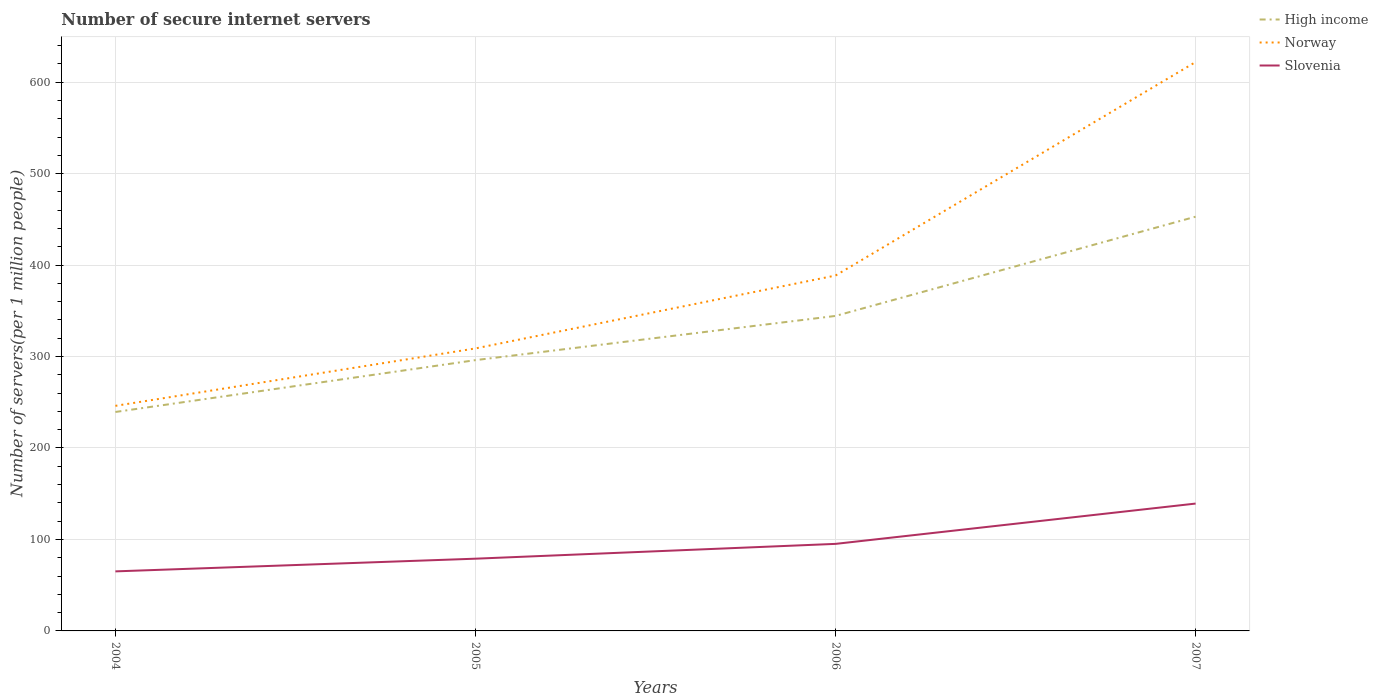How many different coloured lines are there?
Make the answer very short. 3. Is the number of lines equal to the number of legend labels?
Provide a short and direct response. Yes. Across all years, what is the maximum number of secure internet servers in High income?
Offer a terse response. 239.39. In which year was the number of secure internet servers in Slovenia maximum?
Keep it short and to the point. 2004. What is the total number of secure internet servers in Slovenia in the graph?
Your answer should be very brief. -16.19. What is the difference between the highest and the second highest number of secure internet servers in Norway?
Offer a terse response. 375.9. How many lines are there?
Provide a short and direct response. 3. Are the values on the major ticks of Y-axis written in scientific E-notation?
Make the answer very short. No. Does the graph contain any zero values?
Your response must be concise. No. Does the graph contain grids?
Offer a very short reply. Yes. Where does the legend appear in the graph?
Provide a short and direct response. Top right. How many legend labels are there?
Provide a succinct answer. 3. What is the title of the graph?
Keep it short and to the point. Number of secure internet servers. Does "Central Europe" appear as one of the legend labels in the graph?
Provide a short and direct response. No. What is the label or title of the Y-axis?
Your answer should be very brief. Number of servers(per 1 million people). What is the Number of servers(per 1 million people) of High income in 2004?
Make the answer very short. 239.39. What is the Number of servers(per 1 million people) of Norway in 2004?
Your answer should be compact. 246.08. What is the Number of servers(per 1 million people) in Slovenia in 2004?
Ensure brevity in your answer.  65.1. What is the Number of servers(per 1 million people) in High income in 2005?
Provide a succinct answer. 296.07. What is the Number of servers(per 1 million people) of Norway in 2005?
Keep it short and to the point. 308.87. What is the Number of servers(per 1 million people) of Slovenia in 2005?
Ensure brevity in your answer.  78.98. What is the Number of servers(per 1 million people) in High income in 2006?
Ensure brevity in your answer.  344.4. What is the Number of servers(per 1 million people) in Norway in 2006?
Keep it short and to the point. 388.57. What is the Number of servers(per 1 million people) in Slovenia in 2006?
Offer a terse response. 95.17. What is the Number of servers(per 1 million people) of High income in 2007?
Make the answer very short. 452.9. What is the Number of servers(per 1 million people) of Norway in 2007?
Offer a very short reply. 621.98. What is the Number of servers(per 1 million people) in Slovenia in 2007?
Make the answer very short. 139.24. Across all years, what is the maximum Number of servers(per 1 million people) in High income?
Offer a very short reply. 452.9. Across all years, what is the maximum Number of servers(per 1 million people) of Norway?
Keep it short and to the point. 621.98. Across all years, what is the maximum Number of servers(per 1 million people) of Slovenia?
Ensure brevity in your answer.  139.24. Across all years, what is the minimum Number of servers(per 1 million people) of High income?
Offer a terse response. 239.39. Across all years, what is the minimum Number of servers(per 1 million people) in Norway?
Provide a succinct answer. 246.08. Across all years, what is the minimum Number of servers(per 1 million people) in Slovenia?
Give a very brief answer. 65.1. What is the total Number of servers(per 1 million people) of High income in the graph?
Provide a succinct answer. 1332.76. What is the total Number of servers(per 1 million people) of Norway in the graph?
Keep it short and to the point. 1565.51. What is the total Number of servers(per 1 million people) of Slovenia in the graph?
Your answer should be very brief. 378.49. What is the difference between the Number of servers(per 1 million people) of High income in 2004 and that in 2005?
Ensure brevity in your answer.  -56.67. What is the difference between the Number of servers(per 1 million people) in Norway in 2004 and that in 2005?
Offer a terse response. -62.79. What is the difference between the Number of servers(per 1 million people) of Slovenia in 2004 and that in 2005?
Offer a terse response. -13.88. What is the difference between the Number of servers(per 1 million people) in High income in 2004 and that in 2006?
Keep it short and to the point. -105.01. What is the difference between the Number of servers(per 1 million people) in Norway in 2004 and that in 2006?
Make the answer very short. -142.49. What is the difference between the Number of servers(per 1 million people) of Slovenia in 2004 and that in 2006?
Make the answer very short. -30.08. What is the difference between the Number of servers(per 1 million people) of High income in 2004 and that in 2007?
Your answer should be compact. -213.51. What is the difference between the Number of servers(per 1 million people) in Norway in 2004 and that in 2007?
Keep it short and to the point. -375.9. What is the difference between the Number of servers(per 1 million people) of Slovenia in 2004 and that in 2007?
Your response must be concise. -74.14. What is the difference between the Number of servers(per 1 million people) in High income in 2005 and that in 2006?
Offer a very short reply. -48.34. What is the difference between the Number of servers(per 1 million people) in Norway in 2005 and that in 2006?
Your answer should be very brief. -79.7. What is the difference between the Number of servers(per 1 million people) in Slovenia in 2005 and that in 2006?
Make the answer very short. -16.19. What is the difference between the Number of servers(per 1 million people) of High income in 2005 and that in 2007?
Offer a terse response. -156.84. What is the difference between the Number of servers(per 1 million people) in Norway in 2005 and that in 2007?
Provide a short and direct response. -313.11. What is the difference between the Number of servers(per 1 million people) of Slovenia in 2005 and that in 2007?
Make the answer very short. -60.26. What is the difference between the Number of servers(per 1 million people) of High income in 2006 and that in 2007?
Give a very brief answer. -108.5. What is the difference between the Number of servers(per 1 million people) in Norway in 2006 and that in 2007?
Make the answer very short. -233.41. What is the difference between the Number of servers(per 1 million people) in Slovenia in 2006 and that in 2007?
Provide a succinct answer. -44.07. What is the difference between the Number of servers(per 1 million people) of High income in 2004 and the Number of servers(per 1 million people) of Norway in 2005?
Make the answer very short. -69.48. What is the difference between the Number of servers(per 1 million people) of High income in 2004 and the Number of servers(per 1 million people) of Slovenia in 2005?
Your answer should be very brief. 160.41. What is the difference between the Number of servers(per 1 million people) of Norway in 2004 and the Number of servers(per 1 million people) of Slovenia in 2005?
Your answer should be very brief. 167.1. What is the difference between the Number of servers(per 1 million people) of High income in 2004 and the Number of servers(per 1 million people) of Norway in 2006?
Make the answer very short. -149.18. What is the difference between the Number of servers(per 1 million people) of High income in 2004 and the Number of servers(per 1 million people) of Slovenia in 2006?
Offer a terse response. 144.22. What is the difference between the Number of servers(per 1 million people) of Norway in 2004 and the Number of servers(per 1 million people) of Slovenia in 2006?
Ensure brevity in your answer.  150.91. What is the difference between the Number of servers(per 1 million people) in High income in 2004 and the Number of servers(per 1 million people) in Norway in 2007?
Ensure brevity in your answer.  -382.59. What is the difference between the Number of servers(per 1 million people) of High income in 2004 and the Number of servers(per 1 million people) of Slovenia in 2007?
Your answer should be compact. 100.15. What is the difference between the Number of servers(per 1 million people) in Norway in 2004 and the Number of servers(per 1 million people) in Slovenia in 2007?
Offer a very short reply. 106.85. What is the difference between the Number of servers(per 1 million people) of High income in 2005 and the Number of servers(per 1 million people) of Norway in 2006?
Provide a short and direct response. -92.5. What is the difference between the Number of servers(per 1 million people) in High income in 2005 and the Number of servers(per 1 million people) in Slovenia in 2006?
Your answer should be very brief. 200.89. What is the difference between the Number of servers(per 1 million people) in Norway in 2005 and the Number of servers(per 1 million people) in Slovenia in 2006?
Ensure brevity in your answer.  213.7. What is the difference between the Number of servers(per 1 million people) in High income in 2005 and the Number of servers(per 1 million people) in Norway in 2007?
Provide a succinct answer. -325.91. What is the difference between the Number of servers(per 1 million people) in High income in 2005 and the Number of servers(per 1 million people) in Slovenia in 2007?
Give a very brief answer. 156.83. What is the difference between the Number of servers(per 1 million people) of Norway in 2005 and the Number of servers(per 1 million people) of Slovenia in 2007?
Provide a short and direct response. 169.63. What is the difference between the Number of servers(per 1 million people) in High income in 2006 and the Number of servers(per 1 million people) in Norway in 2007?
Your answer should be very brief. -277.58. What is the difference between the Number of servers(per 1 million people) of High income in 2006 and the Number of servers(per 1 million people) of Slovenia in 2007?
Offer a terse response. 205.17. What is the difference between the Number of servers(per 1 million people) in Norway in 2006 and the Number of servers(per 1 million people) in Slovenia in 2007?
Provide a short and direct response. 249.33. What is the average Number of servers(per 1 million people) in High income per year?
Ensure brevity in your answer.  333.19. What is the average Number of servers(per 1 million people) of Norway per year?
Your answer should be compact. 391.38. What is the average Number of servers(per 1 million people) of Slovenia per year?
Your answer should be compact. 94.62. In the year 2004, what is the difference between the Number of servers(per 1 million people) of High income and Number of servers(per 1 million people) of Norway?
Your response must be concise. -6.69. In the year 2004, what is the difference between the Number of servers(per 1 million people) of High income and Number of servers(per 1 million people) of Slovenia?
Provide a short and direct response. 174.29. In the year 2004, what is the difference between the Number of servers(per 1 million people) of Norway and Number of servers(per 1 million people) of Slovenia?
Give a very brief answer. 180.99. In the year 2005, what is the difference between the Number of servers(per 1 million people) in High income and Number of servers(per 1 million people) in Norway?
Give a very brief answer. -12.8. In the year 2005, what is the difference between the Number of servers(per 1 million people) in High income and Number of servers(per 1 million people) in Slovenia?
Your response must be concise. 217.09. In the year 2005, what is the difference between the Number of servers(per 1 million people) of Norway and Number of servers(per 1 million people) of Slovenia?
Your response must be concise. 229.89. In the year 2006, what is the difference between the Number of servers(per 1 million people) of High income and Number of servers(per 1 million people) of Norway?
Ensure brevity in your answer.  -44.17. In the year 2006, what is the difference between the Number of servers(per 1 million people) of High income and Number of servers(per 1 million people) of Slovenia?
Your answer should be compact. 249.23. In the year 2006, what is the difference between the Number of servers(per 1 million people) in Norway and Number of servers(per 1 million people) in Slovenia?
Your answer should be compact. 293.4. In the year 2007, what is the difference between the Number of servers(per 1 million people) in High income and Number of servers(per 1 million people) in Norway?
Provide a succinct answer. -169.08. In the year 2007, what is the difference between the Number of servers(per 1 million people) of High income and Number of servers(per 1 million people) of Slovenia?
Make the answer very short. 313.66. In the year 2007, what is the difference between the Number of servers(per 1 million people) of Norway and Number of servers(per 1 million people) of Slovenia?
Your answer should be very brief. 482.74. What is the ratio of the Number of servers(per 1 million people) in High income in 2004 to that in 2005?
Give a very brief answer. 0.81. What is the ratio of the Number of servers(per 1 million people) in Norway in 2004 to that in 2005?
Provide a short and direct response. 0.8. What is the ratio of the Number of servers(per 1 million people) in Slovenia in 2004 to that in 2005?
Give a very brief answer. 0.82. What is the ratio of the Number of servers(per 1 million people) in High income in 2004 to that in 2006?
Offer a very short reply. 0.7. What is the ratio of the Number of servers(per 1 million people) of Norway in 2004 to that in 2006?
Your answer should be very brief. 0.63. What is the ratio of the Number of servers(per 1 million people) of Slovenia in 2004 to that in 2006?
Ensure brevity in your answer.  0.68. What is the ratio of the Number of servers(per 1 million people) of High income in 2004 to that in 2007?
Your answer should be very brief. 0.53. What is the ratio of the Number of servers(per 1 million people) of Norway in 2004 to that in 2007?
Keep it short and to the point. 0.4. What is the ratio of the Number of servers(per 1 million people) of Slovenia in 2004 to that in 2007?
Offer a very short reply. 0.47. What is the ratio of the Number of servers(per 1 million people) of High income in 2005 to that in 2006?
Your response must be concise. 0.86. What is the ratio of the Number of servers(per 1 million people) of Norway in 2005 to that in 2006?
Offer a terse response. 0.79. What is the ratio of the Number of servers(per 1 million people) in Slovenia in 2005 to that in 2006?
Provide a short and direct response. 0.83. What is the ratio of the Number of servers(per 1 million people) in High income in 2005 to that in 2007?
Your answer should be very brief. 0.65. What is the ratio of the Number of servers(per 1 million people) of Norway in 2005 to that in 2007?
Make the answer very short. 0.5. What is the ratio of the Number of servers(per 1 million people) in Slovenia in 2005 to that in 2007?
Ensure brevity in your answer.  0.57. What is the ratio of the Number of servers(per 1 million people) in High income in 2006 to that in 2007?
Offer a very short reply. 0.76. What is the ratio of the Number of servers(per 1 million people) in Norway in 2006 to that in 2007?
Provide a succinct answer. 0.62. What is the ratio of the Number of servers(per 1 million people) in Slovenia in 2006 to that in 2007?
Offer a very short reply. 0.68. What is the difference between the highest and the second highest Number of servers(per 1 million people) in High income?
Provide a succinct answer. 108.5. What is the difference between the highest and the second highest Number of servers(per 1 million people) of Norway?
Your response must be concise. 233.41. What is the difference between the highest and the second highest Number of servers(per 1 million people) in Slovenia?
Give a very brief answer. 44.07. What is the difference between the highest and the lowest Number of servers(per 1 million people) of High income?
Your answer should be compact. 213.51. What is the difference between the highest and the lowest Number of servers(per 1 million people) of Norway?
Offer a terse response. 375.9. What is the difference between the highest and the lowest Number of servers(per 1 million people) of Slovenia?
Offer a very short reply. 74.14. 